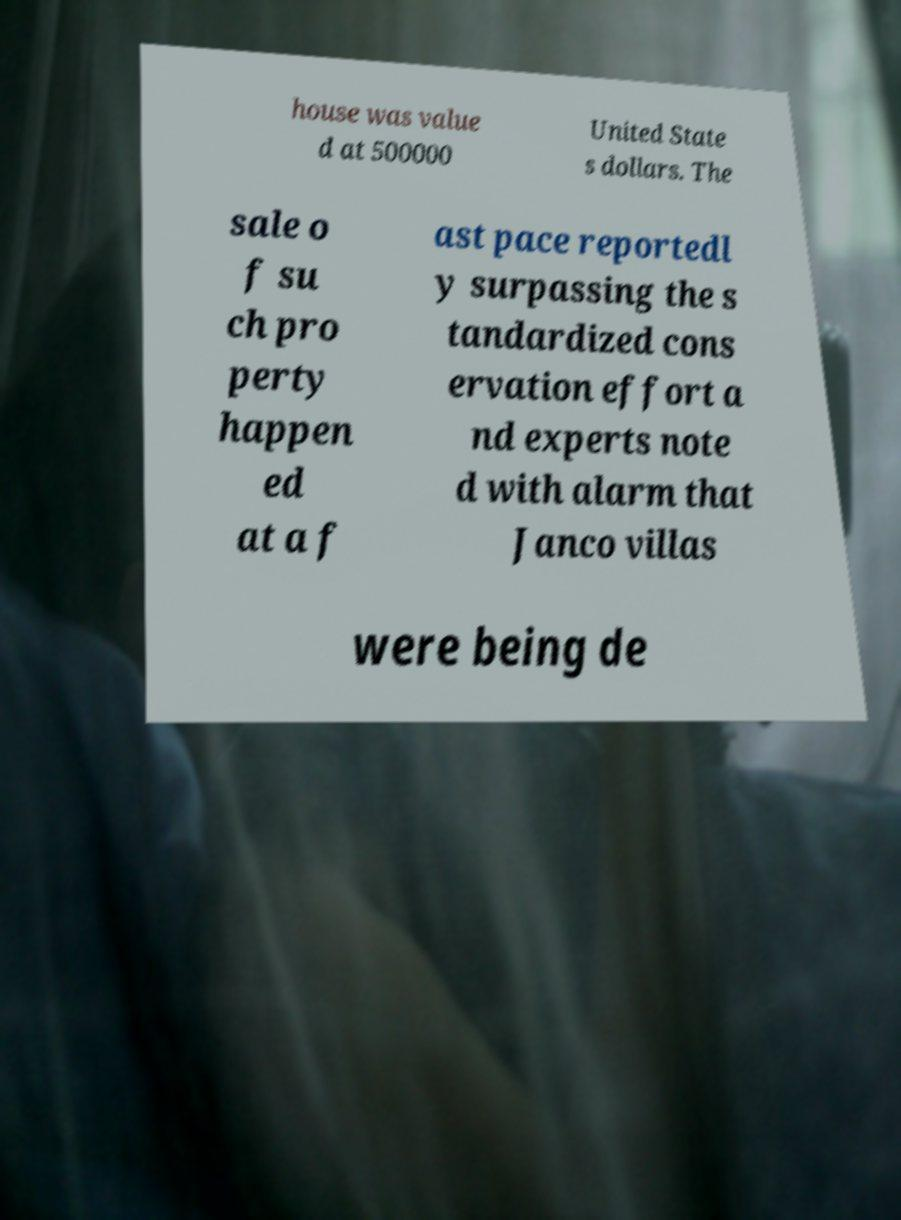Please identify and transcribe the text found in this image. house was value d at 500000 United State s dollars. The sale o f su ch pro perty happen ed at a f ast pace reportedl y surpassing the s tandardized cons ervation effort a nd experts note d with alarm that Janco villas were being de 